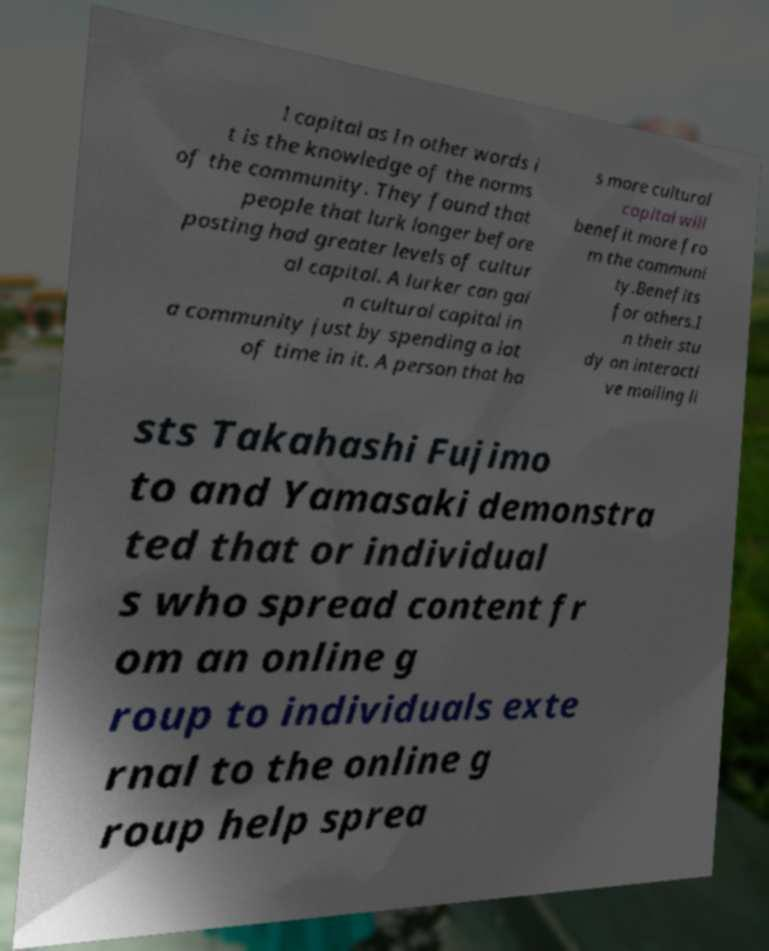Could you extract and type out the text from this image? l capital as In other words i t is the knowledge of the norms of the community. They found that people that lurk longer before posting had greater levels of cultur al capital. A lurker can gai n cultural capital in a community just by spending a lot of time in it. A person that ha s more cultural capital will benefit more fro m the communi ty.Benefits for others.I n their stu dy on interacti ve mailing li sts Takahashi Fujimo to and Yamasaki demonstra ted that or individual s who spread content fr om an online g roup to individuals exte rnal to the online g roup help sprea 